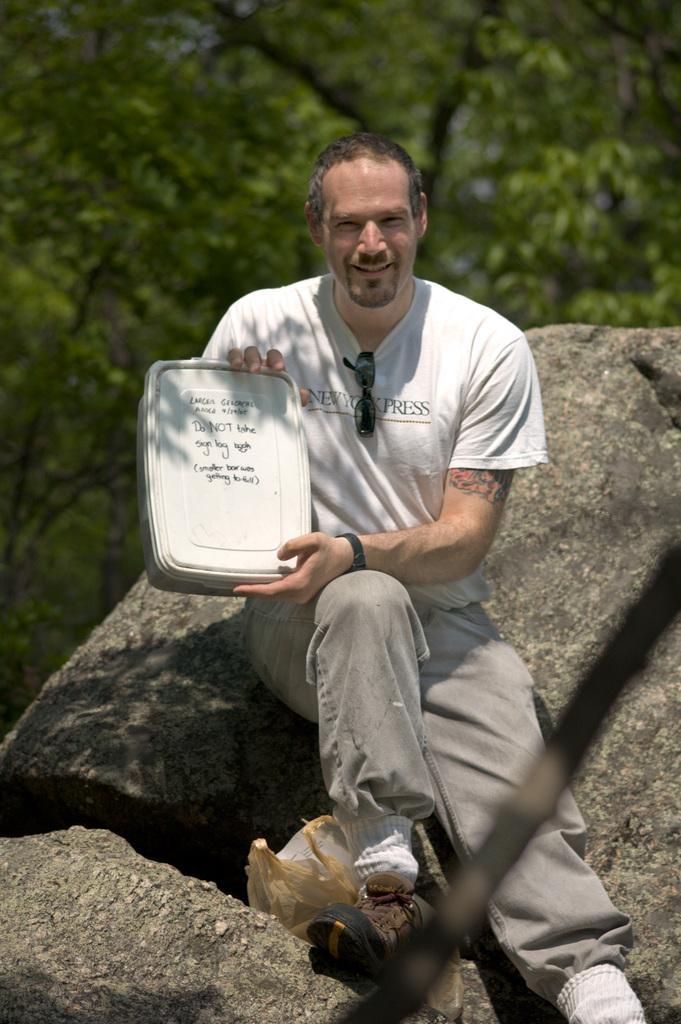In one or two sentences, can you explain what this image depicts? In this image there is a person, box, rocks, trees and objects. In the background of the image there are trees. Person is holding a box.   